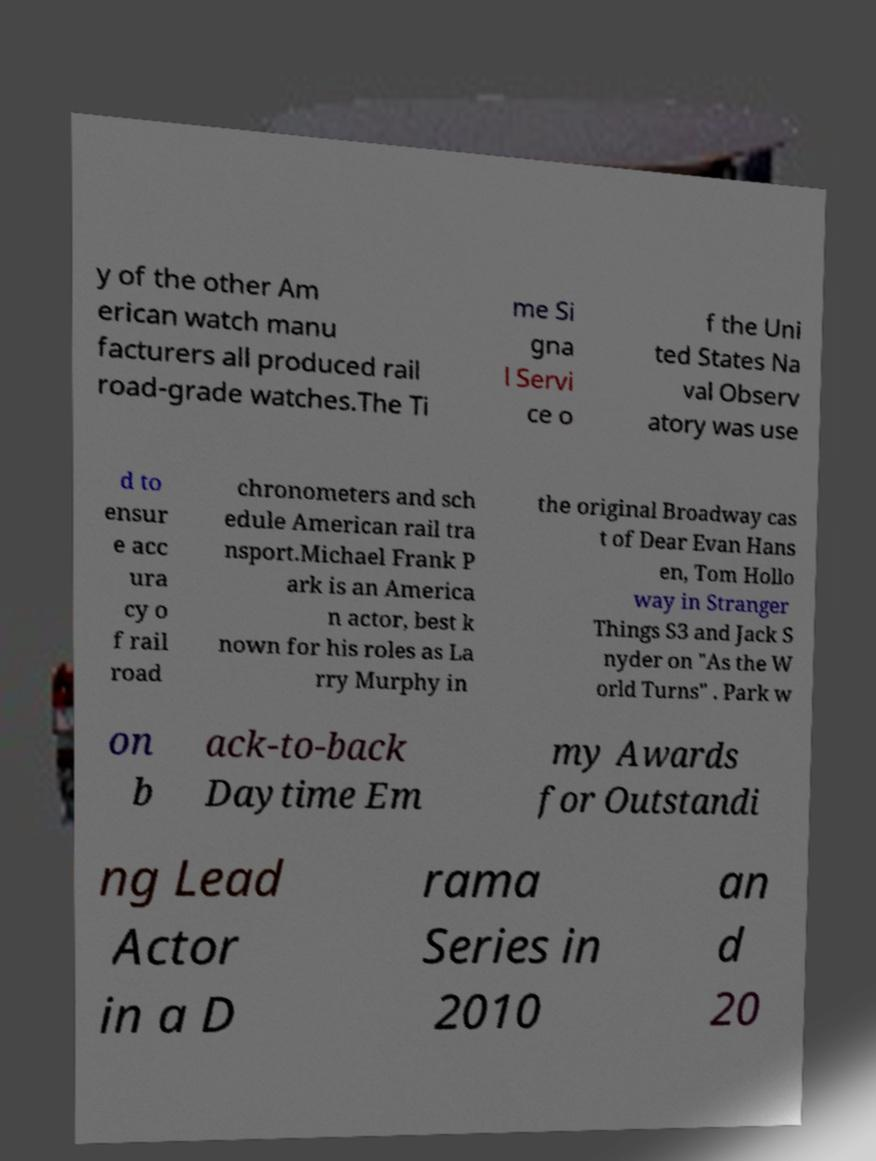Please read and relay the text visible in this image. What does it say? y of the other Am erican watch manu facturers all produced rail road-grade watches.The Ti me Si gna l Servi ce o f the Uni ted States Na val Observ atory was use d to ensur e acc ura cy o f rail road chronometers and sch edule American rail tra nsport.Michael Frank P ark is an America n actor, best k nown for his roles as La rry Murphy in the original Broadway cas t of Dear Evan Hans en, Tom Hollo way in Stranger Things S3 and Jack S nyder on "As the W orld Turns" . Park w on b ack-to-back Daytime Em my Awards for Outstandi ng Lead Actor in a D rama Series in 2010 an d 20 